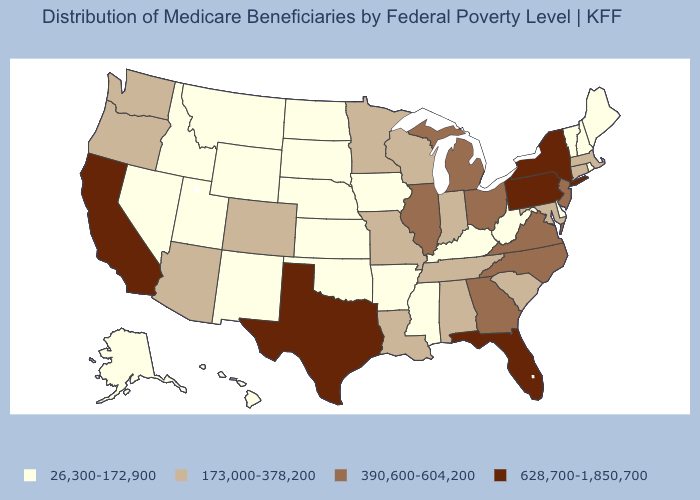Which states have the highest value in the USA?
Write a very short answer. California, Florida, New York, Pennsylvania, Texas. What is the value of California?
Quick response, please. 628,700-1,850,700. Does Kansas have the highest value in the USA?
Answer briefly. No. What is the value of Kansas?
Give a very brief answer. 26,300-172,900. What is the value of Nebraska?
Concise answer only. 26,300-172,900. Among the states that border Pennsylvania , which have the lowest value?
Write a very short answer. Delaware, West Virginia. Among the states that border Washington , does Idaho have the lowest value?
Give a very brief answer. Yes. What is the value of Alaska?
Give a very brief answer. 26,300-172,900. Name the states that have a value in the range 26,300-172,900?
Keep it brief. Alaska, Arkansas, Delaware, Hawaii, Idaho, Iowa, Kansas, Kentucky, Maine, Mississippi, Montana, Nebraska, Nevada, New Hampshire, New Mexico, North Dakota, Oklahoma, Rhode Island, South Dakota, Utah, Vermont, West Virginia, Wyoming. Among the states that border New York , which have the highest value?
Concise answer only. Pennsylvania. Name the states that have a value in the range 390,600-604,200?
Answer briefly. Georgia, Illinois, Michigan, New Jersey, North Carolina, Ohio, Virginia. Name the states that have a value in the range 390,600-604,200?
Give a very brief answer. Georgia, Illinois, Michigan, New Jersey, North Carolina, Ohio, Virginia. Does the first symbol in the legend represent the smallest category?
Short answer required. Yes. Name the states that have a value in the range 628,700-1,850,700?
Give a very brief answer. California, Florida, New York, Pennsylvania, Texas. 